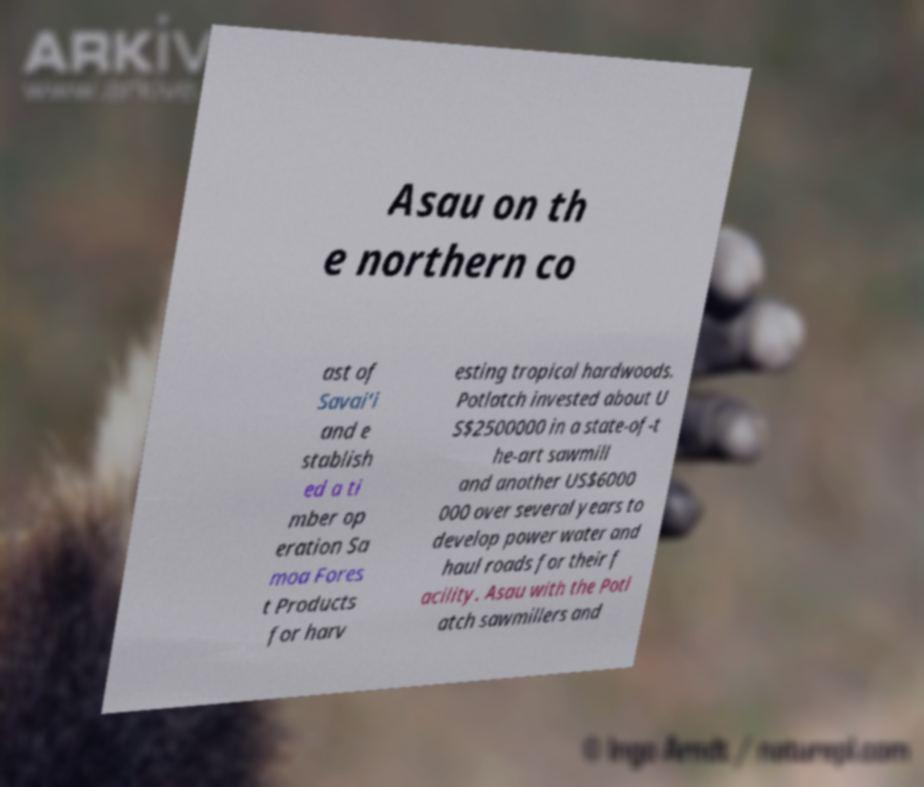Please read and relay the text visible in this image. What does it say? Asau on th e northern co ast of Savai'i and e stablish ed a ti mber op eration Sa moa Fores t Products for harv esting tropical hardwoods. Potlatch invested about U S$2500000 in a state-of-t he-art sawmill and another US$6000 000 over several years to develop power water and haul roads for their f acility. Asau with the Potl atch sawmillers and 